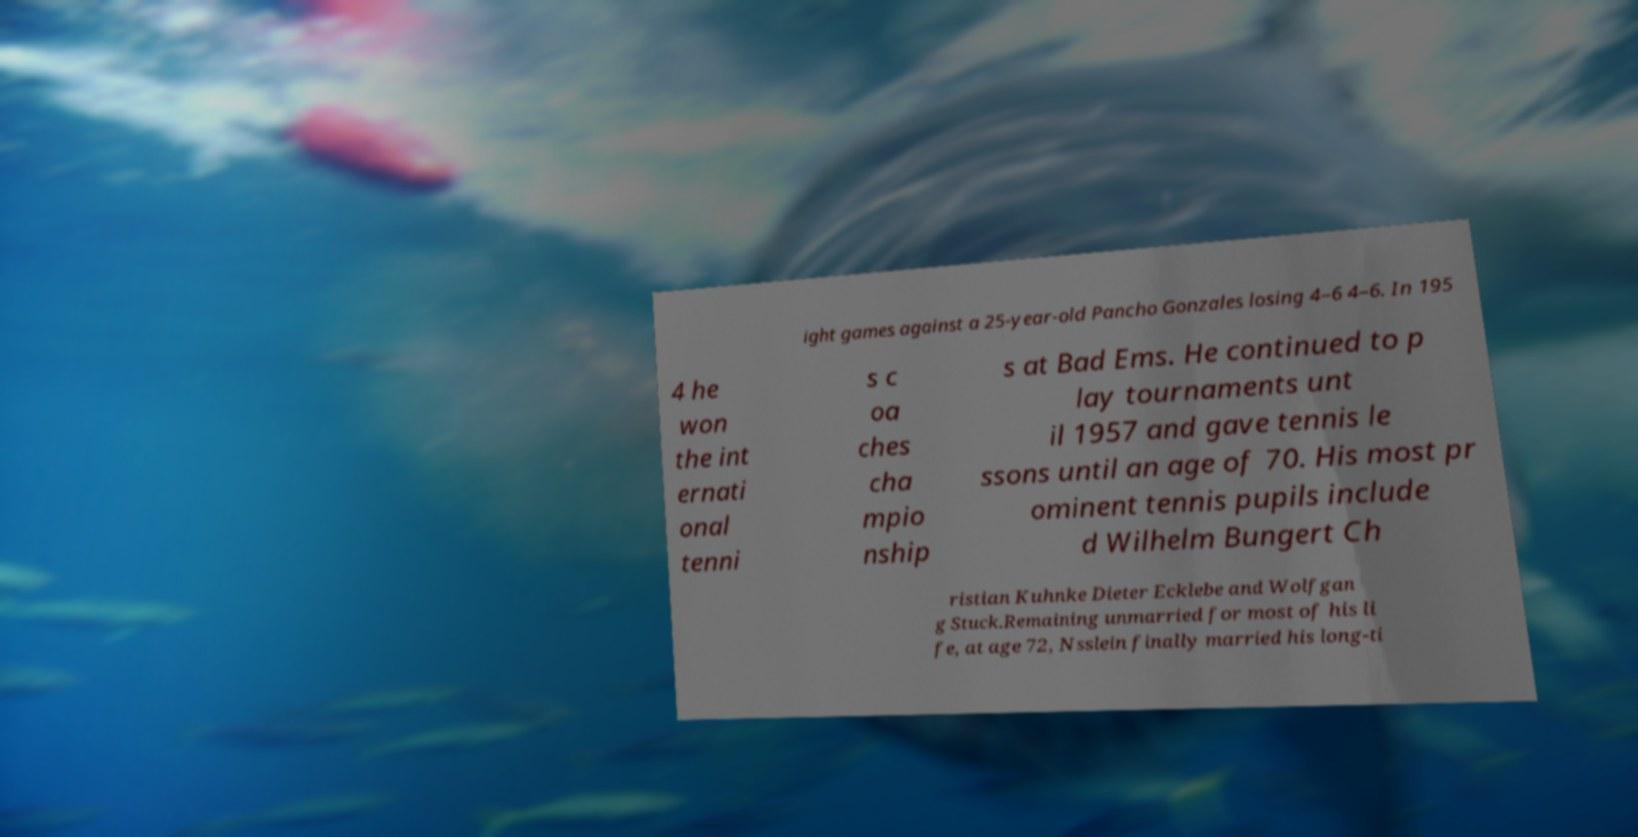Can you read and provide the text displayed in the image?This photo seems to have some interesting text. Can you extract and type it out for me? ight games against a 25-year-old Pancho Gonzales losing 4–6 4–6. In 195 4 he won the int ernati onal tenni s c oa ches cha mpio nship s at Bad Ems. He continued to p lay tournaments unt il 1957 and gave tennis le ssons until an age of 70. His most pr ominent tennis pupils include d Wilhelm Bungert Ch ristian Kuhnke Dieter Ecklebe and Wolfgan g Stuck.Remaining unmarried for most of his li fe, at age 72, Nsslein finally married his long-ti 